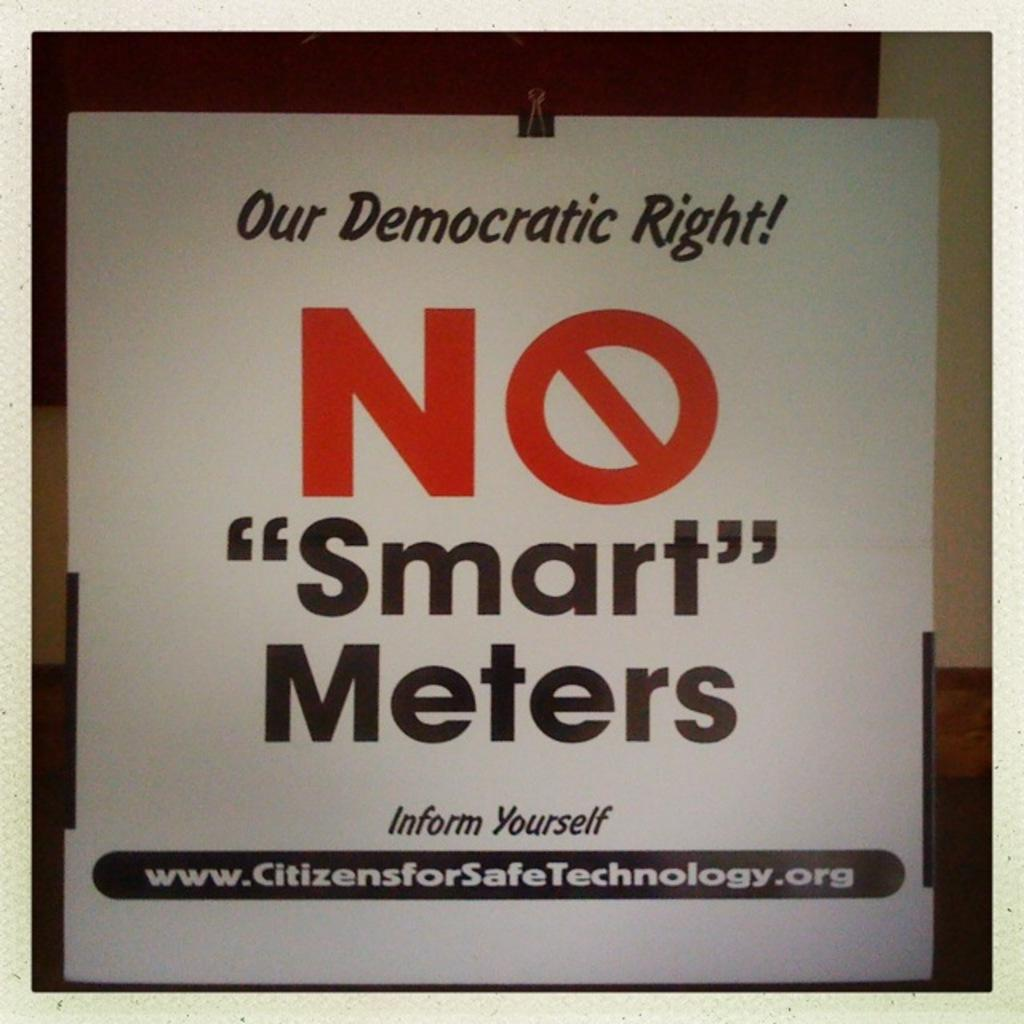What is the main subject in the center of the image? There is a white color poster in the center of the image. What can be found on the poster? The poster contains text. What is visible in the background of the image? There is a wall in the background of the image. What type of cream is being applied to the wall in the image? There is no cream being applied to the wall in the image; the wall is simply visible in the background. 